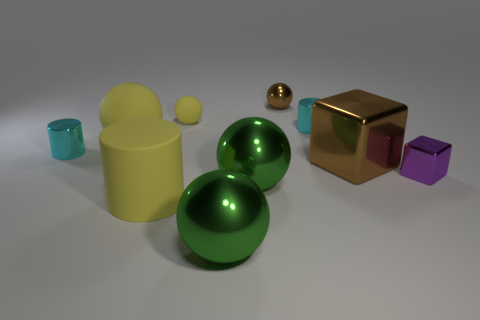Subtract all cyan cylinders. How many cylinders are left? 1 Subtract all brown blocks. How many blocks are left? 1 Subtract all cylinders. How many objects are left? 7 Add 5 cyan metallic objects. How many cyan metallic objects are left? 7 Add 2 rubber cylinders. How many rubber cylinders exist? 3 Subtract 0 yellow blocks. How many objects are left? 10 Subtract 2 cylinders. How many cylinders are left? 1 Subtract all gray cylinders. Subtract all green cubes. How many cylinders are left? 3 Subtract all cyan cylinders. How many purple cubes are left? 1 Subtract all small metal balls. Subtract all large blocks. How many objects are left? 8 